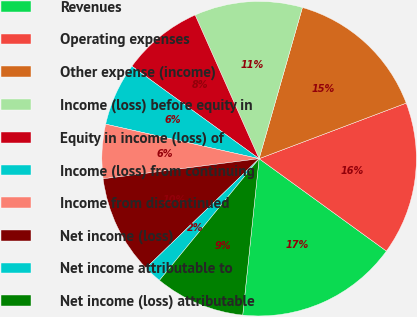<chart> <loc_0><loc_0><loc_500><loc_500><pie_chart><fcel>Revenues<fcel>Operating expenses<fcel>Other expense (income)<fcel>Income (loss) before equity in<fcel>Equity in income (loss) of<fcel>Income (loss) from continuing<fcel>Income from discontinued<fcel>Net income (loss)<fcel>Net income attributable to<fcel>Net income (loss) attributable<nl><fcel>16.67%<fcel>15.74%<fcel>14.81%<fcel>11.11%<fcel>8.33%<fcel>6.48%<fcel>5.56%<fcel>10.19%<fcel>1.85%<fcel>9.26%<nl></chart> 